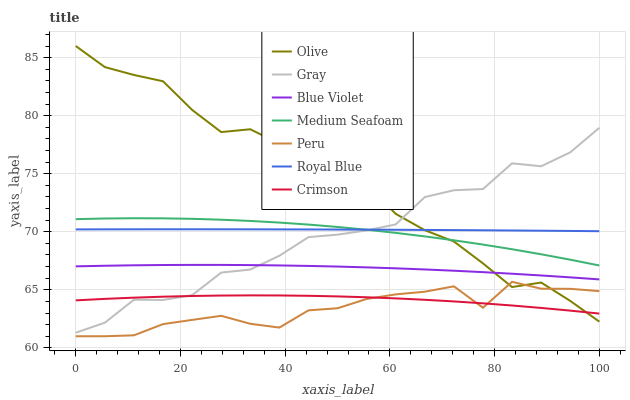Does Royal Blue have the minimum area under the curve?
Answer yes or no. No. Does Royal Blue have the maximum area under the curve?
Answer yes or no. No. Is Peru the smoothest?
Answer yes or no. No. Is Peru the roughest?
Answer yes or no. No. Does Royal Blue have the lowest value?
Answer yes or no. No. Does Royal Blue have the highest value?
Answer yes or no. No. Is Crimson less than Medium Seafoam?
Answer yes or no. Yes. Is Blue Violet greater than Crimson?
Answer yes or no. Yes. Does Crimson intersect Medium Seafoam?
Answer yes or no. No. 